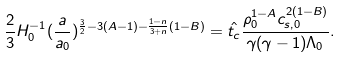<formula> <loc_0><loc_0><loc_500><loc_500>\frac { 2 } { 3 } H _ { 0 } ^ { - 1 } ( \frac { a } { a _ { 0 } } ) ^ { \frac { 3 } { 2 } - 3 ( A - 1 ) - \frac { 1 - n } { 3 + n } ( 1 - B ) } = \hat { t _ { c } } \frac { \rho _ { 0 } ^ { 1 - A } c _ { s , 0 } ^ { 2 ( 1 - B ) } } { \gamma ( \gamma - 1 ) \Lambda _ { 0 } } .</formula> 